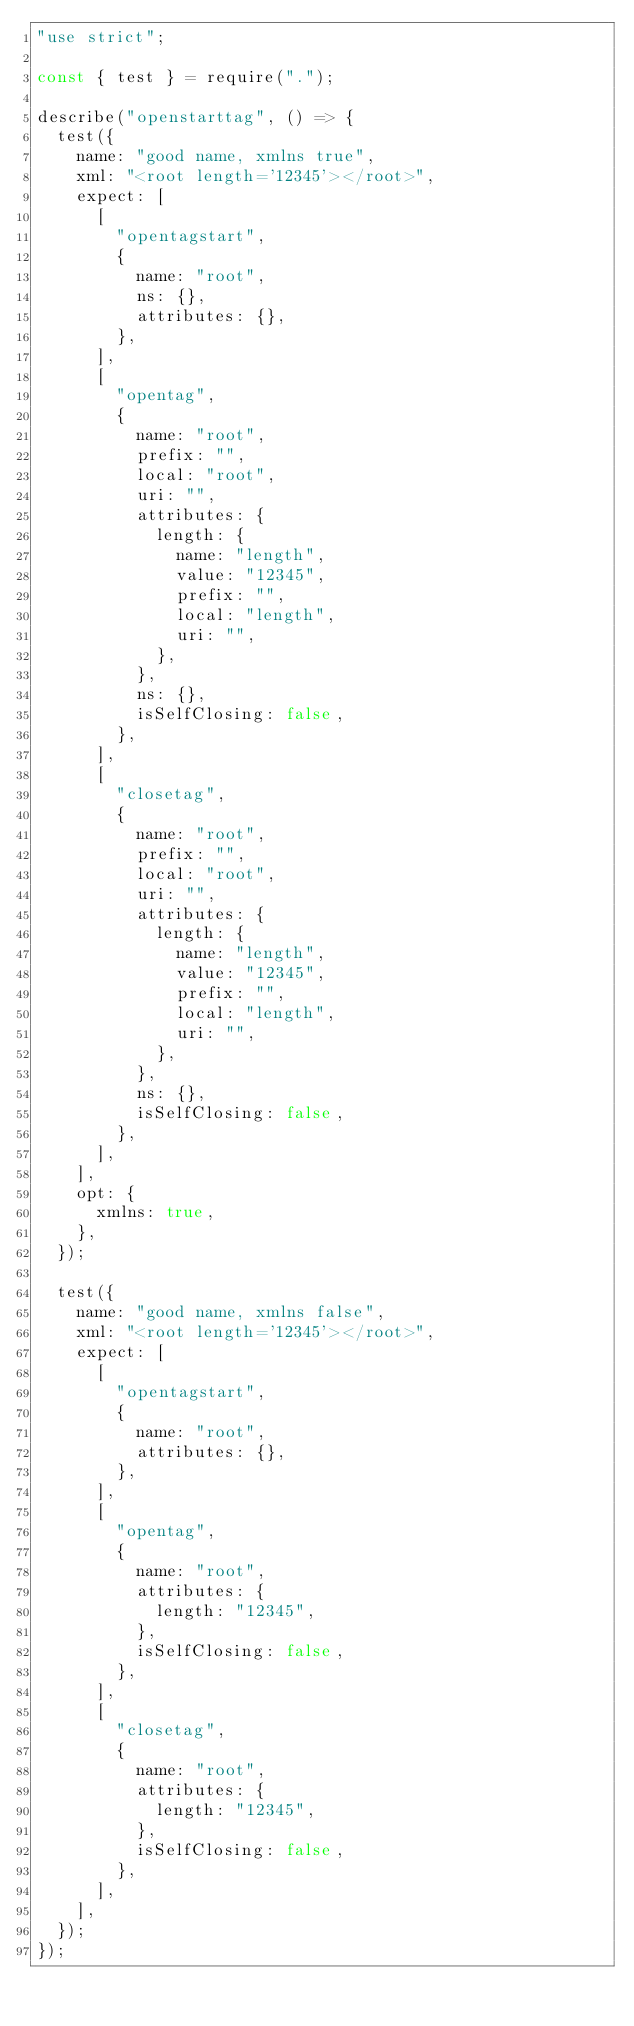Convert code to text. <code><loc_0><loc_0><loc_500><loc_500><_JavaScript_>"use strict";

const { test } = require(".");

describe("openstarttag", () => {
  test({
    name: "good name, xmlns true",
    xml: "<root length='12345'></root>",
    expect: [
      [
        "opentagstart",
        {
          name: "root",
          ns: {},
          attributes: {},
        },
      ],
      [
        "opentag",
        {
          name: "root",
          prefix: "",
          local: "root",
          uri: "",
          attributes: {
            length: {
              name: "length",
              value: "12345",
              prefix: "",
              local: "length",
              uri: "",
            },
          },
          ns: {},
          isSelfClosing: false,
        },
      ],
      [
        "closetag",
        {
          name: "root",
          prefix: "",
          local: "root",
          uri: "",
          attributes: {
            length: {
              name: "length",
              value: "12345",
              prefix: "",
              local: "length",
              uri: "",
            },
          },
          ns: {},
          isSelfClosing: false,
        },
      ],
    ],
    opt: {
      xmlns: true,
    },
  });

  test({
    name: "good name, xmlns false",
    xml: "<root length='12345'></root>",
    expect: [
      [
        "opentagstart",
        {
          name: "root",
          attributes: {},
        },
      ],
      [
        "opentag",
        {
          name: "root",
          attributes: {
            length: "12345",
          },
          isSelfClosing: false,
        },
      ],
      [
        "closetag",
        {
          name: "root",
          attributes: {
            length: "12345",
          },
          isSelfClosing: false,
        },
      ],
    ],
  });
});
</code> 